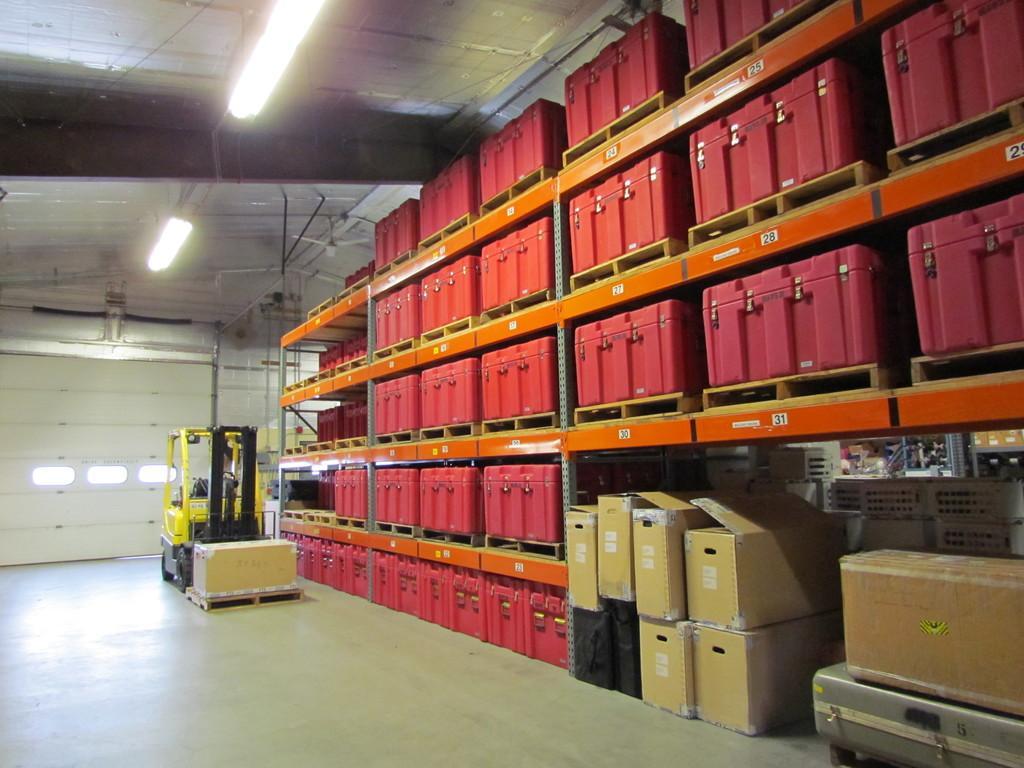Can you describe this image briefly? This is an inside view of a shed. On the right side, I can see many red color boxes which are arranged in the racks. Along with these boxes I can see few card boxes also. On the left side, I can see a vehicle on the floor. In the background, I can see the wall. At the top there are some lights. 